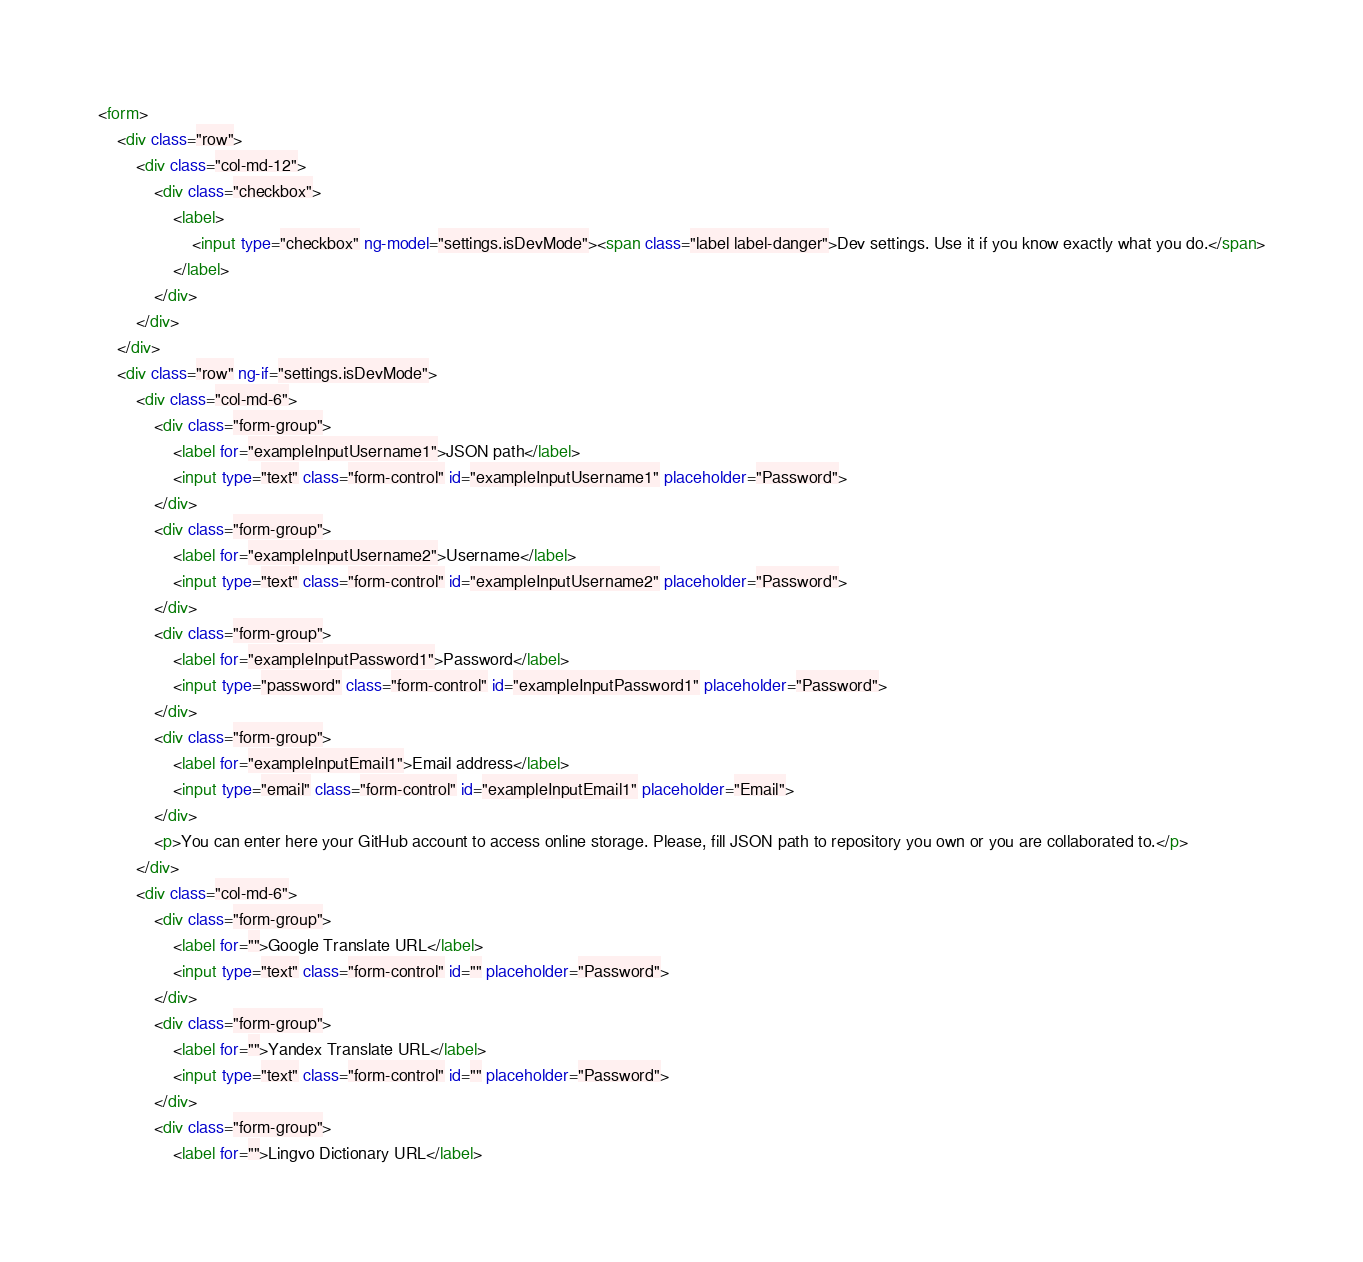Convert code to text. <code><loc_0><loc_0><loc_500><loc_500><_HTML_><form>
    <div class="row">
        <div class="col-md-12">
            <div class="checkbox">
                <label>
                    <input type="checkbox" ng-model="settings.isDevMode"><span class="label label-danger">Dev settings. Use it if you know exactly what you do.</span>
                </label>
            </div>
        </div>
    </div>
    <div class="row" ng-if="settings.isDevMode">
        <div class="col-md-6">
            <div class="form-group">
                <label for="exampleInputUsername1">JSON path</label>
                <input type="text" class="form-control" id="exampleInputUsername1" placeholder="Password">
            </div>
            <div class="form-group">
                <label for="exampleInputUsername2">Username</label>
                <input type="text" class="form-control" id="exampleInputUsername2" placeholder="Password">
            </div>
            <div class="form-group">
                <label for="exampleInputPassword1">Password</label>
                <input type="password" class="form-control" id="exampleInputPassword1" placeholder="Password">
            </div>
            <div class="form-group">
                <label for="exampleInputEmail1">Email address</label>
                <input type="email" class="form-control" id="exampleInputEmail1" placeholder="Email">
            </div>
            <p>You can enter here your GitHub account to access online storage. Please, fill JSON path to repository you own or you are collaborated to.</p>
        </div>
        <div class="col-md-6">
            <div class="form-group">
                <label for="">Google Translate URL</label>
                <input type="text" class="form-control" id="" placeholder="Password">
            </div>
            <div class="form-group">
                <label for="">Yandex Translate URL</label>
                <input type="text" class="form-control" id="" placeholder="Password">
            </div>
            <div class="form-group">
                <label for="">Lingvo Dictionary URL</label></code> 